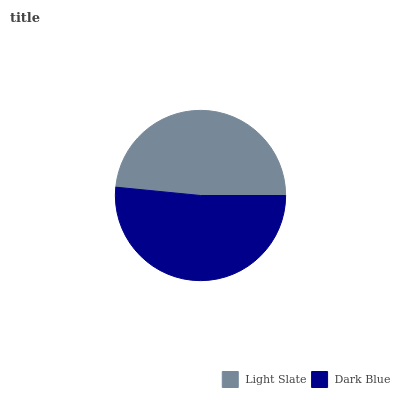Is Light Slate the minimum?
Answer yes or no. Yes. Is Dark Blue the maximum?
Answer yes or no. Yes. Is Dark Blue the minimum?
Answer yes or no. No. Is Dark Blue greater than Light Slate?
Answer yes or no. Yes. Is Light Slate less than Dark Blue?
Answer yes or no. Yes. Is Light Slate greater than Dark Blue?
Answer yes or no. No. Is Dark Blue less than Light Slate?
Answer yes or no. No. Is Dark Blue the high median?
Answer yes or no. Yes. Is Light Slate the low median?
Answer yes or no. Yes. Is Light Slate the high median?
Answer yes or no. No. Is Dark Blue the low median?
Answer yes or no. No. 